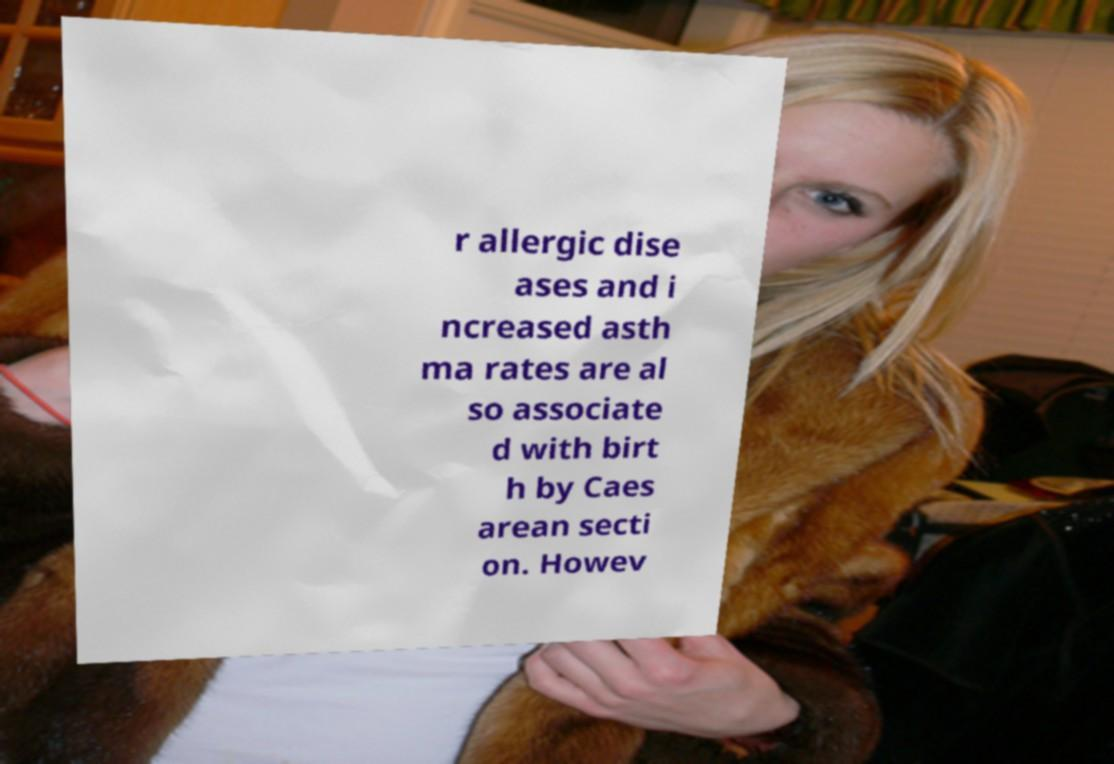Can you accurately transcribe the text from the provided image for me? r allergic dise ases and i ncreased asth ma rates are al so associate d with birt h by Caes arean secti on. Howev 